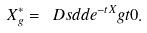Convert formula to latex. <formula><loc_0><loc_0><loc_500><loc_500>X ^ { * } _ { g } = \ D s d d { e ^ { - t X } g } { t } { 0 } .</formula> 